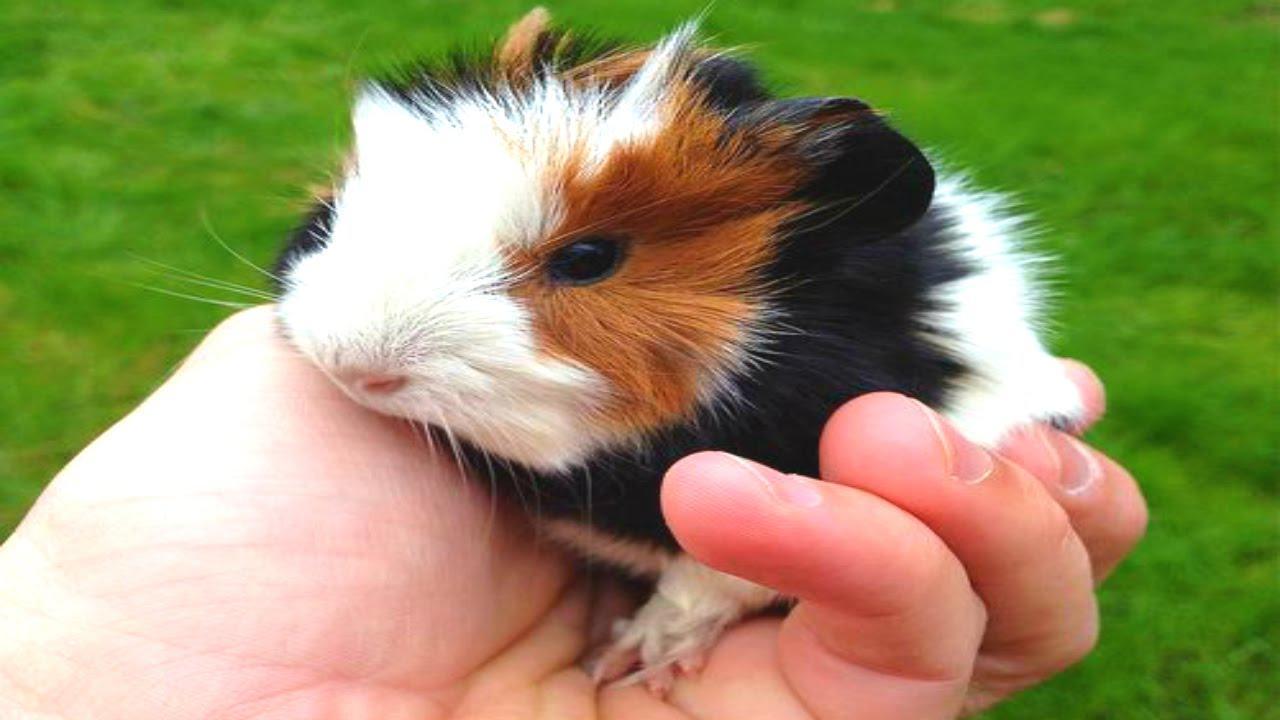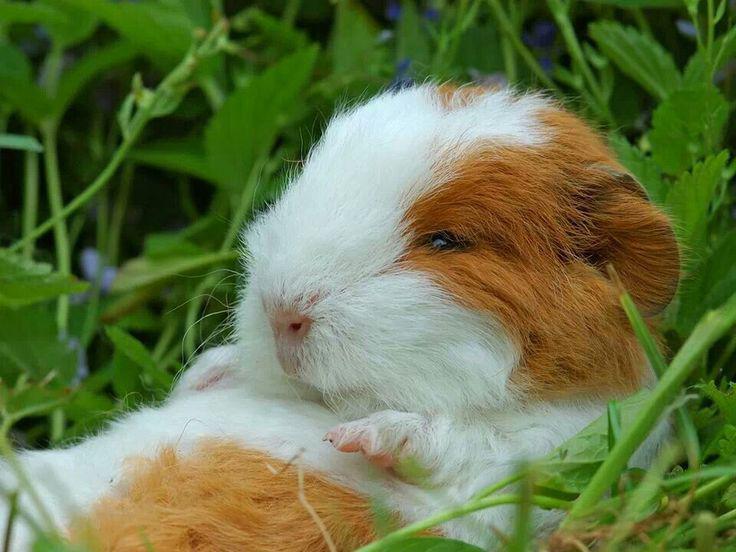The first image is the image on the left, the second image is the image on the right. Examine the images to the left and right. Is the description "One of the images shows only one hamster wearing something on its head." accurate? Answer yes or no. No. The first image is the image on the left, the second image is the image on the right. Examine the images to the left and right. Is the description "An image shows just one hamster wearing something decorative on its head." accurate? Answer yes or no. No. 